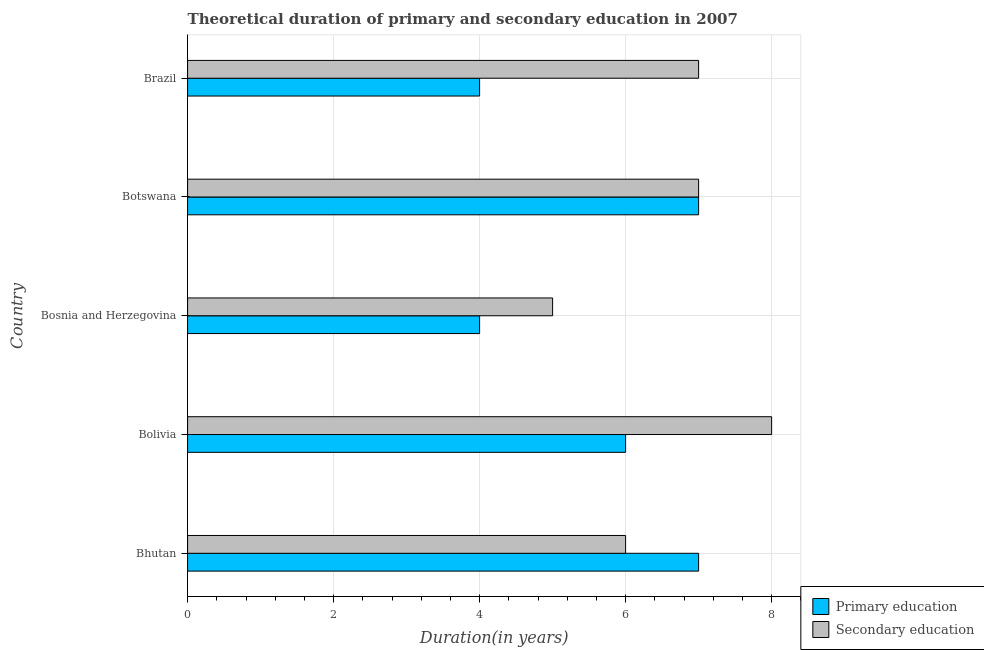How many different coloured bars are there?
Ensure brevity in your answer.  2. Are the number of bars on each tick of the Y-axis equal?
Ensure brevity in your answer.  Yes. How many bars are there on the 4th tick from the bottom?
Your answer should be compact. 2. What is the label of the 3rd group of bars from the top?
Provide a short and direct response. Bosnia and Herzegovina. In how many cases, is the number of bars for a given country not equal to the number of legend labels?
Give a very brief answer. 0. What is the duration of secondary education in Brazil?
Your answer should be very brief. 7. Across all countries, what is the maximum duration of primary education?
Offer a very short reply. 7. Across all countries, what is the minimum duration of primary education?
Offer a terse response. 4. In which country was the duration of secondary education maximum?
Your response must be concise. Bolivia. In which country was the duration of primary education minimum?
Keep it short and to the point. Bosnia and Herzegovina. What is the total duration of secondary education in the graph?
Your response must be concise. 33. What is the difference between the duration of secondary education in Bolivia and that in Brazil?
Provide a succinct answer. 1. What is the difference between the duration of secondary education in Bhutan and the duration of primary education in Bosnia and Herzegovina?
Provide a succinct answer. 2. What is the average duration of primary education per country?
Your response must be concise. 5.6. What is the difference between the duration of secondary education and duration of primary education in Botswana?
Offer a terse response. 0. What is the ratio of the duration of primary education in Bhutan to that in Bosnia and Herzegovina?
Your answer should be very brief. 1.75. What is the difference between the highest and the lowest duration of primary education?
Give a very brief answer. 3. Is the sum of the duration of secondary education in Bolivia and Brazil greater than the maximum duration of primary education across all countries?
Provide a short and direct response. Yes. What does the 2nd bar from the top in Bosnia and Herzegovina represents?
Keep it short and to the point. Primary education. What does the 1st bar from the bottom in Bhutan represents?
Provide a succinct answer. Primary education. Are all the bars in the graph horizontal?
Provide a short and direct response. Yes. How many countries are there in the graph?
Offer a very short reply. 5. Does the graph contain any zero values?
Your answer should be compact. No. What is the title of the graph?
Ensure brevity in your answer.  Theoretical duration of primary and secondary education in 2007. What is the label or title of the X-axis?
Make the answer very short. Duration(in years). What is the label or title of the Y-axis?
Ensure brevity in your answer.  Country. What is the Duration(in years) of Secondary education in Bhutan?
Offer a very short reply. 6. What is the Duration(in years) of Primary education in Bolivia?
Offer a very short reply. 6. What is the Duration(in years) of Secondary education in Bolivia?
Keep it short and to the point. 8. What is the Duration(in years) in Primary education in Bosnia and Herzegovina?
Your answer should be compact. 4. What is the Duration(in years) in Secondary education in Bosnia and Herzegovina?
Make the answer very short. 5. What is the Duration(in years) of Primary education in Botswana?
Offer a terse response. 7. Across all countries, what is the maximum Duration(in years) of Primary education?
Ensure brevity in your answer.  7. Across all countries, what is the maximum Duration(in years) in Secondary education?
Provide a short and direct response. 8. Across all countries, what is the minimum Duration(in years) in Primary education?
Give a very brief answer. 4. Across all countries, what is the minimum Duration(in years) of Secondary education?
Give a very brief answer. 5. What is the total Duration(in years) of Primary education in the graph?
Ensure brevity in your answer.  28. What is the difference between the Duration(in years) of Primary education in Bhutan and that in Bolivia?
Offer a terse response. 1. What is the difference between the Duration(in years) in Secondary education in Bhutan and that in Bolivia?
Provide a succinct answer. -2. What is the difference between the Duration(in years) of Primary education in Bhutan and that in Botswana?
Offer a very short reply. 0. What is the difference between the Duration(in years) in Secondary education in Bhutan and that in Botswana?
Offer a very short reply. -1. What is the difference between the Duration(in years) of Primary education in Bhutan and that in Brazil?
Provide a short and direct response. 3. What is the difference between the Duration(in years) of Secondary education in Bhutan and that in Brazil?
Offer a terse response. -1. What is the difference between the Duration(in years) of Primary education in Bolivia and that in Bosnia and Herzegovina?
Your answer should be very brief. 2. What is the difference between the Duration(in years) of Primary education in Bolivia and that in Botswana?
Your response must be concise. -1. What is the difference between the Duration(in years) of Secondary education in Bolivia and that in Botswana?
Ensure brevity in your answer.  1. What is the difference between the Duration(in years) of Primary education in Bolivia and that in Brazil?
Your answer should be compact. 2. What is the difference between the Duration(in years) in Primary education in Bosnia and Herzegovina and that in Botswana?
Make the answer very short. -3. What is the difference between the Duration(in years) in Secondary education in Bosnia and Herzegovina and that in Botswana?
Ensure brevity in your answer.  -2. What is the difference between the Duration(in years) of Secondary education in Bosnia and Herzegovina and that in Brazil?
Provide a succinct answer. -2. What is the difference between the Duration(in years) of Secondary education in Botswana and that in Brazil?
Keep it short and to the point. 0. What is the difference between the Duration(in years) in Primary education in Bhutan and the Duration(in years) in Secondary education in Bolivia?
Ensure brevity in your answer.  -1. What is the difference between the Duration(in years) of Primary education in Bhutan and the Duration(in years) of Secondary education in Bosnia and Herzegovina?
Your answer should be compact. 2. What is the difference between the Duration(in years) of Primary education in Bhutan and the Duration(in years) of Secondary education in Botswana?
Your answer should be compact. 0. What is the difference between the Duration(in years) of Primary education in Bolivia and the Duration(in years) of Secondary education in Bosnia and Herzegovina?
Provide a short and direct response. 1. What is the difference between the Duration(in years) of Primary education in Bolivia and the Duration(in years) of Secondary education in Botswana?
Offer a very short reply. -1. What is the difference between the Duration(in years) in Primary education in Bolivia and the Duration(in years) in Secondary education in Brazil?
Make the answer very short. -1. What is the difference between the Duration(in years) in Primary education in Bosnia and Herzegovina and the Duration(in years) in Secondary education in Botswana?
Give a very brief answer. -3. What is the difference between the Duration(in years) in Primary education in Bosnia and Herzegovina and the Duration(in years) in Secondary education in Brazil?
Provide a succinct answer. -3. What is the difference between the Duration(in years) in Primary education in Botswana and the Duration(in years) in Secondary education in Brazil?
Make the answer very short. 0. What is the average Duration(in years) of Secondary education per country?
Ensure brevity in your answer.  6.6. What is the difference between the Duration(in years) in Primary education and Duration(in years) in Secondary education in Bhutan?
Keep it short and to the point. 1. What is the difference between the Duration(in years) of Primary education and Duration(in years) of Secondary education in Bosnia and Herzegovina?
Your answer should be very brief. -1. What is the ratio of the Duration(in years) of Primary education in Bhutan to that in Bosnia and Herzegovina?
Give a very brief answer. 1.75. What is the ratio of the Duration(in years) in Primary education in Bhutan to that in Botswana?
Give a very brief answer. 1. What is the ratio of the Duration(in years) of Primary education in Bhutan to that in Brazil?
Offer a very short reply. 1.75. What is the ratio of the Duration(in years) of Secondary education in Bhutan to that in Brazil?
Provide a short and direct response. 0.86. What is the ratio of the Duration(in years) in Secondary education in Bolivia to that in Bosnia and Herzegovina?
Ensure brevity in your answer.  1.6. What is the ratio of the Duration(in years) in Primary education in Bolivia to that in Botswana?
Give a very brief answer. 0.86. What is the ratio of the Duration(in years) in Secondary education in Bolivia to that in Botswana?
Ensure brevity in your answer.  1.14. What is the ratio of the Duration(in years) in Primary education in Bolivia to that in Brazil?
Provide a short and direct response. 1.5. What is the ratio of the Duration(in years) in Secondary education in Bolivia to that in Brazil?
Offer a terse response. 1.14. What is the ratio of the Duration(in years) in Primary education in Bosnia and Herzegovina to that in Botswana?
Your answer should be compact. 0.57. What is the ratio of the Duration(in years) of Secondary education in Bosnia and Herzegovina to that in Botswana?
Your response must be concise. 0.71. What is the ratio of the Duration(in years) in Primary education in Bosnia and Herzegovina to that in Brazil?
Make the answer very short. 1. What is the ratio of the Duration(in years) in Secondary education in Bosnia and Herzegovina to that in Brazil?
Offer a very short reply. 0.71. What is the ratio of the Duration(in years) in Primary education in Botswana to that in Brazil?
Your answer should be compact. 1.75. What is the ratio of the Duration(in years) of Secondary education in Botswana to that in Brazil?
Give a very brief answer. 1. What is the difference between the highest and the second highest Duration(in years) in Primary education?
Make the answer very short. 0. What is the difference between the highest and the second highest Duration(in years) in Secondary education?
Keep it short and to the point. 1. What is the difference between the highest and the lowest Duration(in years) in Primary education?
Keep it short and to the point. 3. 